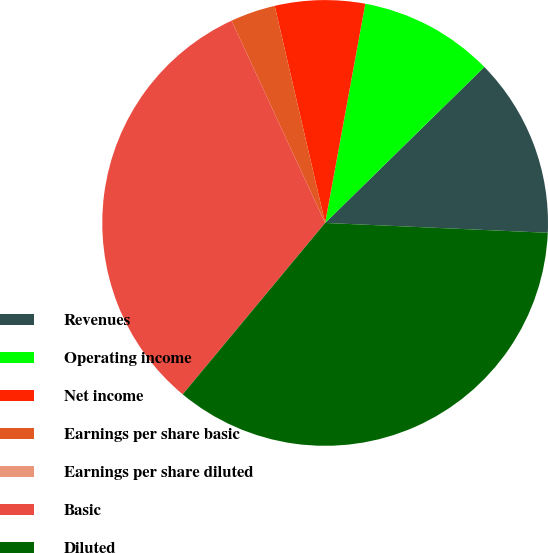Convert chart. <chart><loc_0><loc_0><loc_500><loc_500><pie_chart><fcel>Revenues<fcel>Operating income<fcel>Net income<fcel>Earnings per share basic<fcel>Earnings per share diluted<fcel>Basic<fcel>Diluted<nl><fcel>13.04%<fcel>9.78%<fcel>6.52%<fcel>3.26%<fcel>0.0%<fcel>32.07%<fcel>35.33%<nl></chart> 